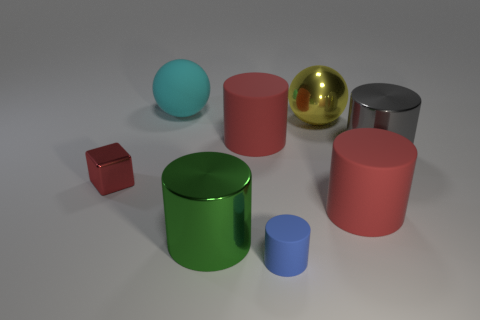There is a matte cylinder that is behind the large gray thing; is its color the same as the small metallic cube?
Your answer should be compact. Yes. The yellow metal thing has what shape?
Your answer should be compact. Sphere. What number of large cyan spheres are the same material as the blue cylinder?
Offer a terse response. 1. Is the color of the tiny metal cube the same as the matte cylinder behind the small metal block?
Give a very brief answer. Yes. How many tiny red metallic cubes are there?
Give a very brief answer. 1. Are there any rubber cylinders that have the same color as the metallic ball?
Your answer should be compact. No. There is a large object to the left of the metal cylinder in front of the shiny thing to the left of the big green metallic object; what color is it?
Keep it short and to the point. Cyan. Is the large cyan object made of the same material as the big red object in front of the red metal block?
Offer a terse response. Yes. What material is the cyan ball?
Your answer should be compact. Rubber. What number of other things are made of the same material as the red block?
Your response must be concise. 3. 